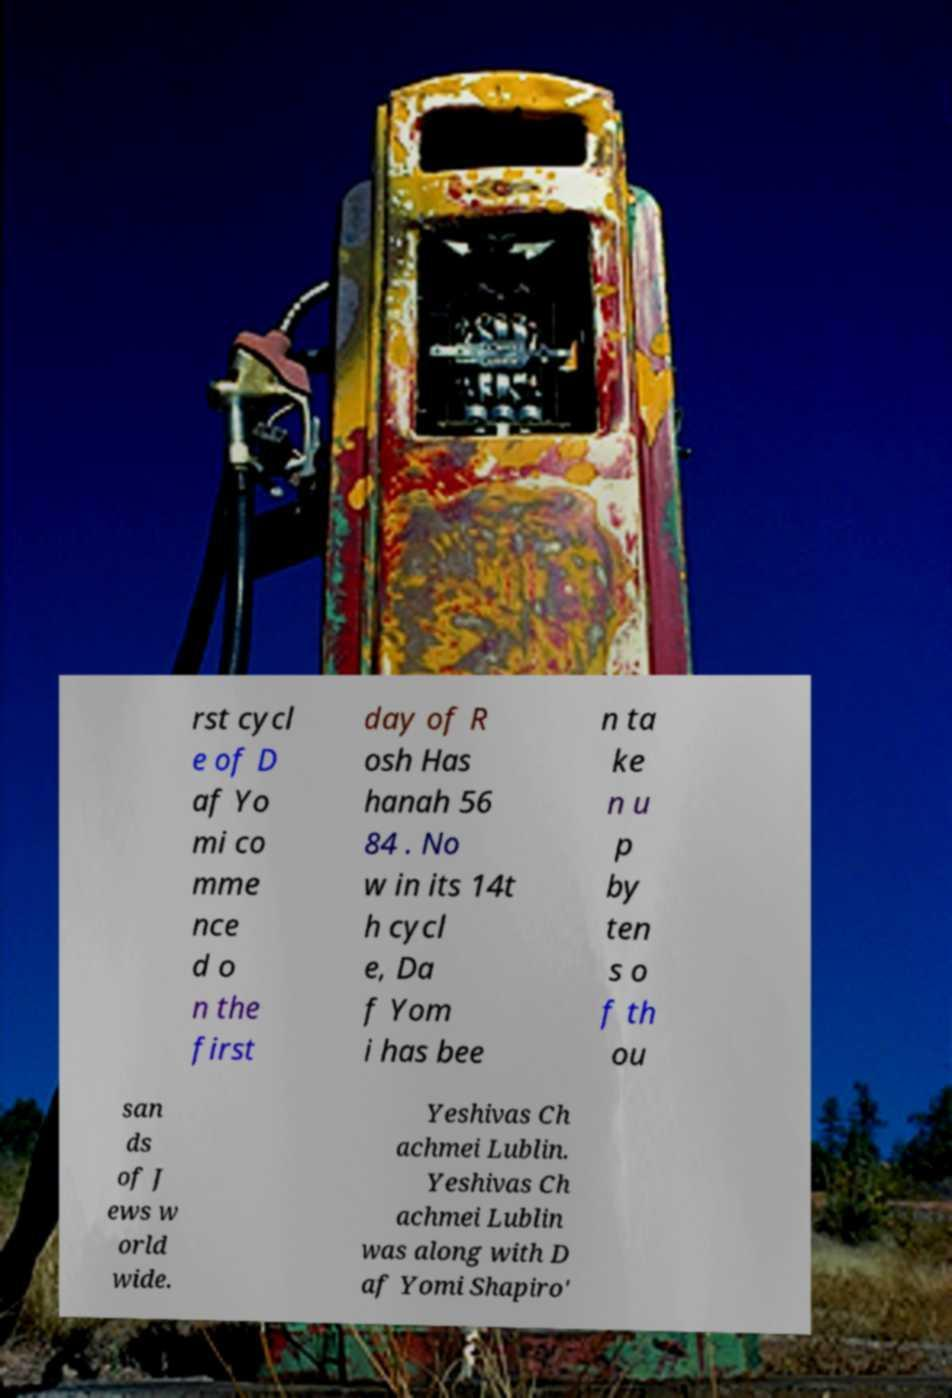Could you assist in decoding the text presented in this image and type it out clearly? rst cycl e of D af Yo mi co mme nce d o n the first day of R osh Has hanah 56 84 . No w in its 14t h cycl e, Da f Yom i has bee n ta ke n u p by ten s o f th ou san ds of J ews w orld wide. Yeshivas Ch achmei Lublin. Yeshivas Ch achmei Lublin was along with D af Yomi Shapiro' 